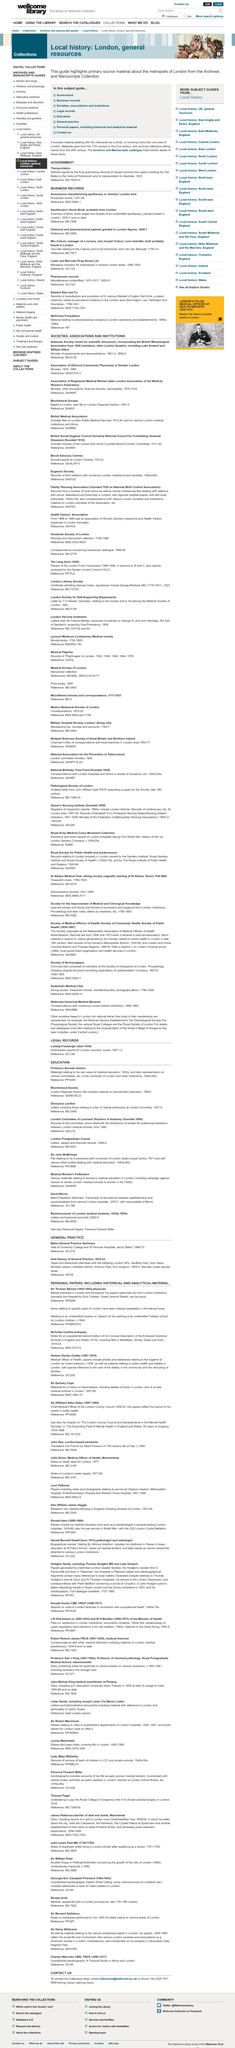Outline some significant characteristics in this image. The Askesian Society consisted of two esteemed members: Luke Howard and William Allen. The prisoners are finally delivered to Australia. The location of the anonymous manufacturers is unknown, but they are believed to be based in the London area. It is required that the warrants be signed by the King. The minutes for the Association of District Community Physicians in Greater London in the years 1976 and 1980 are as follows. 